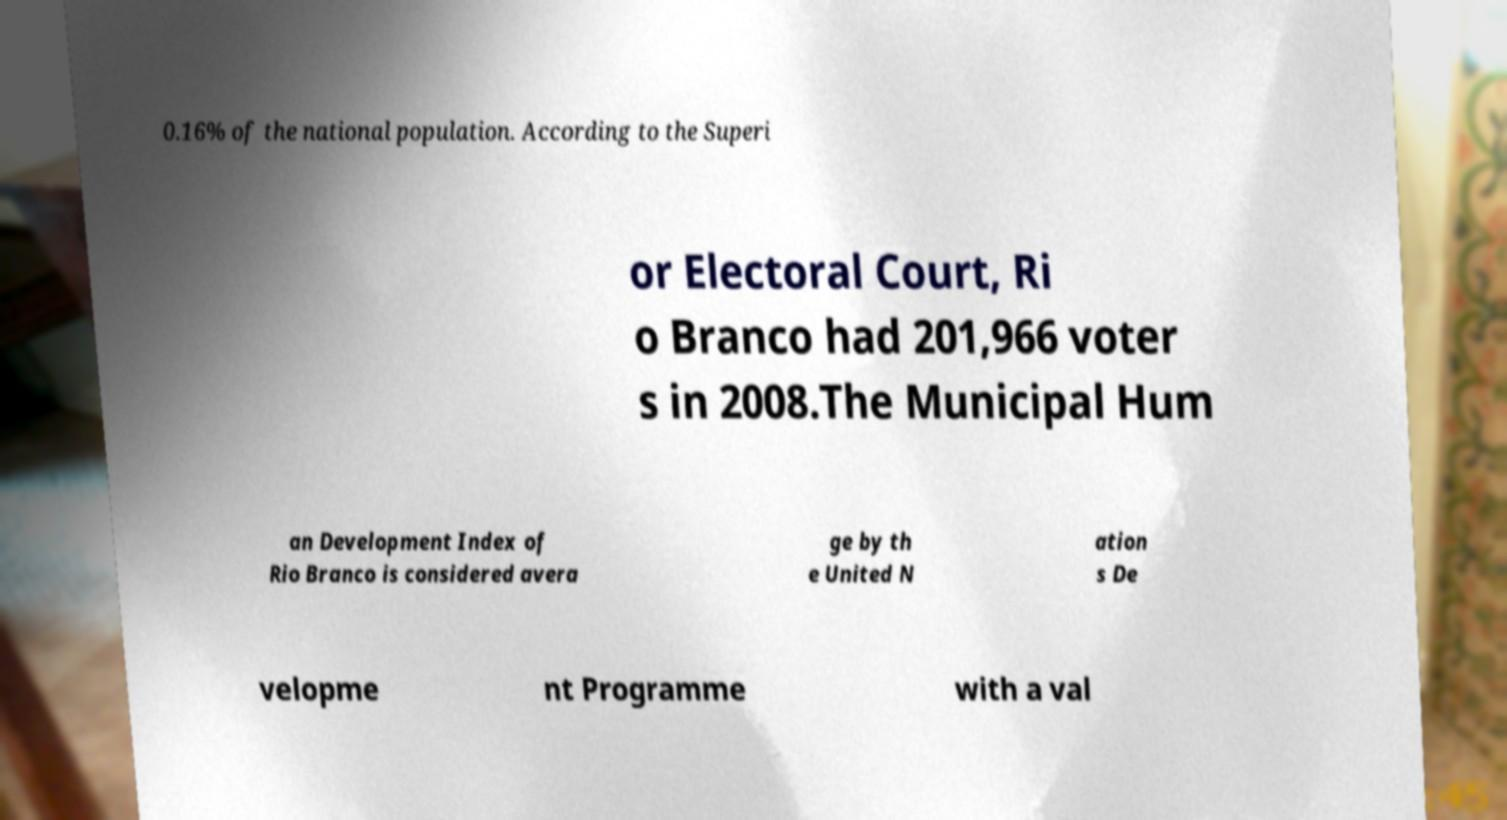Please identify and transcribe the text found in this image. 0.16% of the national population. According to the Superi or Electoral Court, Ri o Branco had 201,966 voter s in 2008.The Municipal Hum an Development Index of Rio Branco is considered avera ge by th e United N ation s De velopme nt Programme with a val 